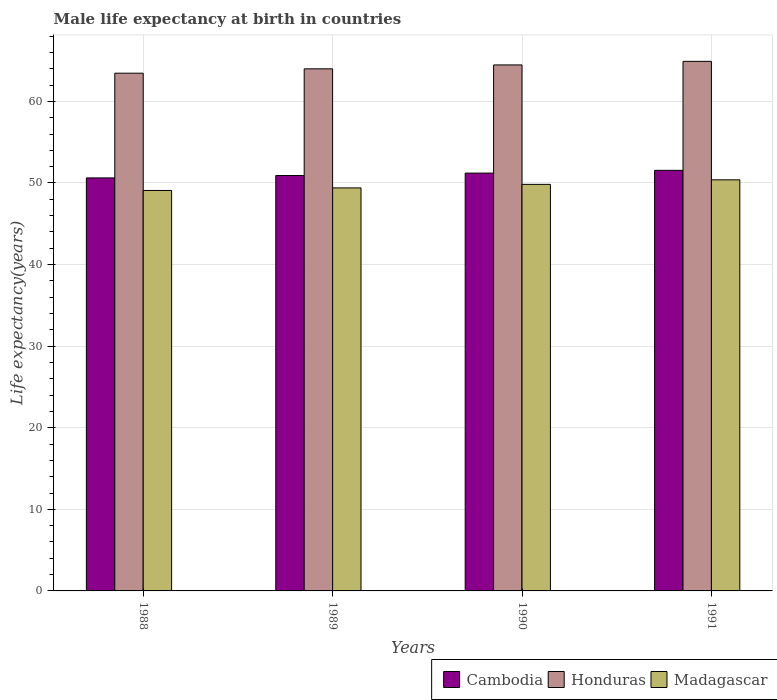How many groups of bars are there?
Keep it short and to the point. 4. Are the number of bars per tick equal to the number of legend labels?
Keep it short and to the point. Yes. Are the number of bars on each tick of the X-axis equal?
Provide a short and direct response. Yes. What is the label of the 4th group of bars from the left?
Offer a terse response. 1991. What is the male life expectancy at birth in Cambodia in 1989?
Provide a short and direct response. 50.92. Across all years, what is the maximum male life expectancy at birth in Honduras?
Offer a terse response. 64.91. Across all years, what is the minimum male life expectancy at birth in Madagascar?
Offer a very short reply. 49.08. What is the total male life expectancy at birth in Honduras in the graph?
Offer a very short reply. 256.83. What is the difference between the male life expectancy at birth in Honduras in 1989 and that in 1990?
Your answer should be very brief. -0.48. What is the difference between the male life expectancy at birth in Cambodia in 1989 and the male life expectancy at birth in Madagascar in 1990?
Provide a short and direct response. 1.08. What is the average male life expectancy at birth in Cambodia per year?
Your answer should be compact. 51.08. In the year 1988, what is the difference between the male life expectancy at birth in Madagascar and male life expectancy at birth in Cambodia?
Offer a very short reply. -1.54. What is the ratio of the male life expectancy at birth in Honduras in 1989 to that in 1991?
Offer a very short reply. 0.99. Is the male life expectancy at birth in Madagascar in 1990 less than that in 1991?
Keep it short and to the point. Yes. Is the difference between the male life expectancy at birth in Madagascar in 1988 and 1991 greater than the difference between the male life expectancy at birth in Cambodia in 1988 and 1991?
Your answer should be very brief. No. What is the difference between the highest and the second highest male life expectancy at birth in Cambodia?
Ensure brevity in your answer.  0.34. What is the difference between the highest and the lowest male life expectancy at birth in Madagascar?
Offer a very short reply. 1.3. Is the sum of the male life expectancy at birth in Cambodia in 1988 and 1990 greater than the maximum male life expectancy at birth in Madagascar across all years?
Provide a succinct answer. Yes. What does the 3rd bar from the left in 1990 represents?
Give a very brief answer. Madagascar. What does the 2nd bar from the right in 1991 represents?
Your answer should be very brief. Honduras. What is the difference between two consecutive major ticks on the Y-axis?
Your answer should be compact. 10. Where does the legend appear in the graph?
Your answer should be very brief. Bottom right. What is the title of the graph?
Offer a very short reply. Male life expectancy at birth in countries. Does "Antigua and Barbuda" appear as one of the legend labels in the graph?
Keep it short and to the point. No. What is the label or title of the Y-axis?
Provide a short and direct response. Life expectancy(years). What is the Life expectancy(years) in Cambodia in 1988?
Give a very brief answer. 50.62. What is the Life expectancy(years) of Honduras in 1988?
Provide a succinct answer. 63.46. What is the Life expectancy(years) in Madagascar in 1988?
Give a very brief answer. 49.08. What is the Life expectancy(years) in Cambodia in 1989?
Your response must be concise. 50.92. What is the Life expectancy(years) of Honduras in 1989?
Your answer should be very brief. 63.99. What is the Life expectancy(years) of Madagascar in 1989?
Provide a short and direct response. 49.4. What is the Life expectancy(years) of Cambodia in 1990?
Provide a short and direct response. 51.21. What is the Life expectancy(years) of Honduras in 1990?
Offer a terse response. 64.47. What is the Life expectancy(years) of Madagascar in 1990?
Ensure brevity in your answer.  49.83. What is the Life expectancy(years) in Cambodia in 1991?
Your answer should be very brief. 51.55. What is the Life expectancy(years) of Honduras in 1991?
Provide a short and direct response. 64.91. What is the Life expectancy(years) of Madagascar in 1991?
Offer a terse response. 50.39. Across all years, what is the maximum Life expectancy(years) of Cambodia?
Offer a very short reply. 51.55. Across all years, what is the maximum Life expectancy(years) in Honduras?
Keep it short and to the point. 64.91. Across all years, what is the maximum Life expectancy(years) in Madagascar?
Provide a short and direct response. 50.39. Across all years, what is the minimum Life expectancy(years) of Cambodia?
Your answer should be very brief. 50.62. Across all years, what is the minimum Life expectancy(years) in Honduras?
Make the answer very short. 63.46. Across all years, what is the minimum Life expectancy(years) in Madagascar?
Keep it short and to the point. 49.08. What is the total Life expectancy(years) in Cambodia in the graph?
Offer a terse response. 204.3. What is the total Life expectancy(years) of Honduras in the graph?
Your answer should be very brief. 256.83. What is the total Life expectancy(years) of Madagascar in the graph?
Offer a terse response. 198.7. What is the difference between the Life expectancy(years) of Cambodia in 1988 and that in 1989?
Provide a succinct answer. -0.29. What is the difference between the Life expectancy(years) in Honduras in 1988 and that in 1989?
Keep it short and to the point. -0.54. What is the difference between the Life expectancy(years) in Madagascar in 1988 and that in 1989?
Your response must be concise. -0.31. What is the difference between the Life expectancy(years) of Cambodia in 1988 and that in 1990?
Your answer should be very brief. -0.59. What is the difference between the Life expectancy(years) of Honduras in 1988 and that in 1990?
Provide a succinct answer. -1.01. What is the difference between the Life expectancy(years) of Madagascar in 1988 and that in 1990?
Ensure brevity in your answer.  -0.75. What is the difference between the Life expectancy(years) in Cambodia in 1988 and that in 1991?
Make the answer very short. -0.93. What is the difference between the Life expectancy(years) in Honduras in 1988 and that in 1991?
Offer a terse response. -1.45. What is the difference between the Life expectancy(years) of Madagascar in 1988 and that in 1991?
Offer a very short reply. -1.3. What is the difference between the Life expectancy(years) of Cambodia in 1989 and that in 1990?
Your response must be concise. -0.3. What is the difference between the Life expectancy(years) in Honduras in 1989 and that in 1990?
Your answer should be very brief. -0.48. What is the difference between the Life expectancy(years) of Madagascar in 1989 and that in 1990?
Your answer should be very brief. -0.43. What is the difference between the Life expectancy(years) in Cambodia in 1989 and that in 1991?
Your response must be concise. -0.63. What is the difference between the Life expectancy(years) of Honduras in 1989 and that in 1991?
Your response must be concise. -0.92. What is the difference between the Life expectancy(years) of Madagascar in 1989 and that in 1991?
Offer a terse response. -0.99. What is the difference between the Life expectancy(years) of Cambodia in 1990 and that in 1991?
Offer a very short reply. -0.34. What is the difference between the Life expectancy(years) of Honduras in 1990 and that in 1991?
Your answer should be compact. -0.44. What is the difference between the Life expectancy(years) of Madagascar in 1990 and that in 1991?
Keep it short and to the point. -0.56. What is the difference between the Life expectancy(years) of Cambodia in 1988 and the Life expectancy(years) of Honduras in 1989?
Provide a succinct answer. -13.37. What is the difference between the Life expectancy(years) in Cambodia in 1988 and the Life expectancy(years) in Madagascar in 1989?
Give a very brief answer. 1.23. What is the difference between the Life expectancy(years) of Honduras in 1988 and the Life expectancy(years) of Madagascar in 1989?
Provide a succinct answer. 14.06. What is the difference between the Life expectancy(years) of Cambodia in 1988 and the Life expectancy(years) of Honduras in 1990?
Your answer should be compact. -13.85. What is the difference between the Life expectancy(years) in Cambodia in 1988 and the Life expectancy(years) in Madagascar in 1990?
Provide a short and direct response. 0.79. What is the difference between the Life expectancy(years) in Honduras in 1988 and the Life expectancy(years) in Madagascar in 1990?
Offer a very short reply. 13.62. What is the difference between the Life expectancy(years) of Cambodia in 1988 and the Life expectancy(years) of Honduras in 1991?
Make the answer very short. -14.29. What is the difference between the Life expectancy(years) in Cambodia in 1988 and the Life expectancy(years) in Madagascar in 1991?
Keep it short and to the point. 0.23. What is the difference between the Life expectancy(years) of Honduras in 1988 and the Life expectancy(years) of Madagascar in 1991?
Your response must be concise. 13.07. What is the difference between the Life expectancy(years) of Cambodia in 1989 and the Life expectancy(years) of Honduras in 1990?
Your answer should be compact. -13.55. What is the difference between the Life expectancy(years) of Cambodia in 1989 and the Life expectancy(years) of Madagascar in 1990?
Your answer should be very brief. 1.08. What is the difference between the Life expectancy(years) of Honduras in 1989 and the Life expectancy(years) of Madagascar in 1990?
Offer a very short reply. 14.16. What is the difference between the Life expectancy(years) in Cambodia in 1989 and the Life expectancy(years) in Honduras in 1991?
Offer a very short reply. -13.99. What is the difference between the Life expectancy(years) of Cambodia in 1989 and the Life expectancy(years) of Madagascar in 1991?
Ensure brevity in your answer.  0.53. What is the difference between the Life expectancy(years) in Honduras in 1989 and the Life expectancy(years) in Madagascar in 1991?
Your response must be concise. 13.6. What is the difference between the Life expectancy(years) of Cambodia in 1990 and the Life expectancy(years) of Honduras in 1991?
Ensure brevity in your answer.  -13.7. What is the difference between the Life expectancy(years) in Cambodia in 1990 and the Life expectancy(years) in Madagascar in 1991?
Ensure brevity in your answer.  0.82. What is the difference between the Life expectancy(years) in Honduras in 1990 and the Life expectancy(years) in Madagascar in 1991?
Give a very brief answer. 14.08. What is the average Life expectancy(years) of Cambodia per year?
Ensure brevity in your answer.  51.08. What is the average Life expectancy(years) in Honduras per year?
Ensure brevity in your answer.  64.21. What is the average Life expectancy(years) of Madagascar per year?
Provide a succinct answer. 49.68. In the year 1988, what is the difference between the Life expectancy(years) in Cambodia and Life expectancy(years) in Honduras?
Your response must be concise. -12.83. In the year 1988, what is the difference between the Life expectancy(years) of Cambodia and Life expectancy(years) of Madagascar?
Make the answer very short. 1.54. In the year 1988, what is the difference between the Life expectancy(years) in Honduras and Life expectancy(years) in Madagascar?
Ensure brevity in your answer.  14.37. In the year 1989, what is the difference between the Life expectancy(years) in Cambodia and Life expectancy(years) in Honduras?
Keep it short and to the point. -13.08. In the year 1989, what is the difference between the Life expectancy(years) of Cambodia and Life expectancy(years) of Madagascar?
Your response must be concise. 1.52. In the year 1989, what is the difference between the Life expectancy(years) of Honduras and Life expectancy(years) of Madagascar?
Your answer should be very brief. 14.59. In the year 1990, what is the difference between the Life expectancy(years) of Cambodia and Life expectancy(years) of Honduras?
Give a very brief answer. -13.26. In the year 1990, what is the difference between the Life expectancy(years) in Cambodia and Life expectancy(years) in Madagascar?
Ensure brevity in your answer.  1.38. In the year 1990, what is the difference between the Life expectancy(years) in Honduras and Life expectancy(years) in Madagascar?
Offer a very short reply. 14.64. In the year 1991, what is the difference between the Life expectancy(years) of Cambodia and Life expectancy(years) of Honduras?
Offer a terse response. -13.36. In the year 1991, what is the difference between the Life expectancy(years) of Cambodia and Life expectancy(years) of Madagascar?
Ensure brevity in your answer.  1.16. In the year 1991, what is the difference between the Life expectancy(years) in Honduras and Life expectancy(years) in Madagascar?
Offer a terse response. 14.52. What is the ratio of the Life expectancy(years) in Cambodia in 1988 to that in 1989?
Offer a terse response. 0.99. What is the ratio of the Life expectancy(years) in Honduras in 1988 to that in 1989?
Offer a very short reply. 0.99. What is the ratio of the Life expectancy(years) of Cambodia in 1988 to that in 1990?
Keep it short and to the point. 0.99. What is the ratio of the Life expectancy(years) in Honduras in 1988 to that in 1990?
Give a very brief answer. 0.98. What is the ratio of the Life expectancy(years) of Honduras in 1988 to that in 1991?
Ensure brevity in your answer.  0.98. What is the ratio of the Life expectancy(years) in Madagascar in 1988 to that in 1991?
Give a very brief answer. 0.97. What is the ratio of the Life expectancy(years) of Cambodia in 1989 to that in 1990?
Offer a very short reply. 0.99. What is the ratio of the Life expectancy(years) of Madagascar in 1989 to that in 1990?
Offer a terse response. 0.99. What is the ratio of the Life expectancy(years) of Honduras in 1989 to that in 1991?
Give a very brief answer. 0.99. What is the ratio of the Life expectancy(years) of Madagascar in 1989 to that in 1991?
Offer a very short reply. 0.98. What is the ratio of the Life expectancy(years) of Honduras in 1990 to that in 1991?
Your answer should be compact. 0.99. What is the difference between the highest and the second highest Life expectancy(years) of Cambodia?
Keep it short and to the point. 0.34. What is the difference between the highest and the second highest Life expectancy(years) in Honduras?
Offer a very short reply. 0.44. What is the difference between the highest and the second highest Life expectancy(years) in Madagascar?
Provide a succinct answer. 0.56. What is the difference between the highest and the lowest Life expectancy(years) in Cambodia?
Give a very brief answer. 0.93. What is the difference between the highest and the lowest Life expectancy(years) in Honduras?
Your answer should be compact. 1.45. What is the difference between the highest and the lowest Life expectancy(years) in Madagascar?
Make the answer very short. 1.3. 